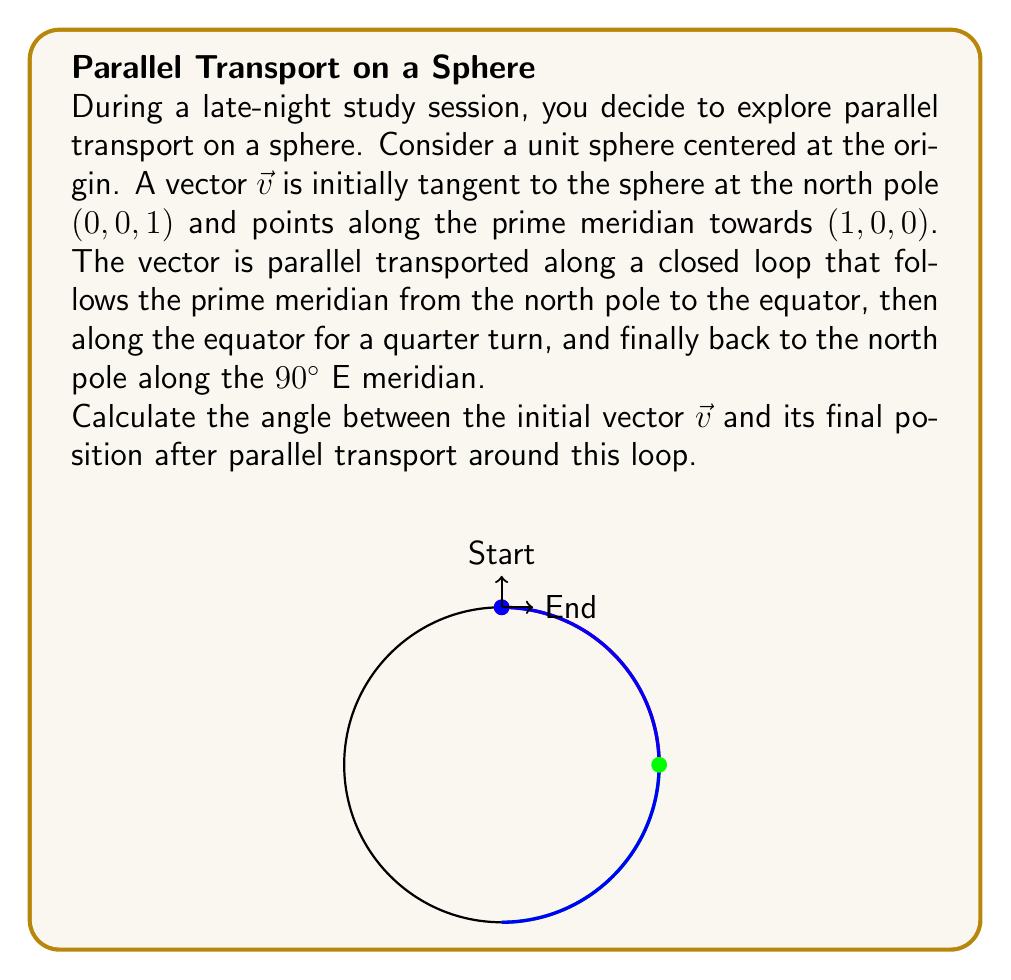Solve this math problem. Let's approach this step-by-step:

1) Parallel transport on a sphere preserves the angle between the vector and the great circle it's being transported along.

2) The total angle of rotation is equal to the solid angle enclosed by the path, which is given by the area of the spherical triangle formed by the path divided by the square of the radius.

3) Our path forms a spherical triangle with three 90° angles (at the north pole, the equator, and where the 90°E meridian meets the equator).

4) The area of a spherical triangle is given by the formula:
   $A = R^2(α + β + γ - π)$
   where $R$ is the radius of the sphere, and $α$, $β$, and $γ$ are the angles of the triangle in radians.

5) In our case, $R = 1$ (unit sphere), and all three angles are $\frac{\pi}{2}$. So:
   $A = 1^2(\frac{\pi}{2} + \frac{\pi}{2} + \frac{\pi}{2} - \pi) = \frac{\pi}{2}$

6) The solid angle $\Omega$ is equal to this area:
   $\Omega = \frac{\pi}{2}$

7) The angle of rotation $\theta$ is equal to this solid angle:
   $\theta = \frac{\pi}{2} = 90°$

Therefore, after parallel transport around this loop, the vector will have rotated by 90° relative to its initial position.
Answer: 90° 